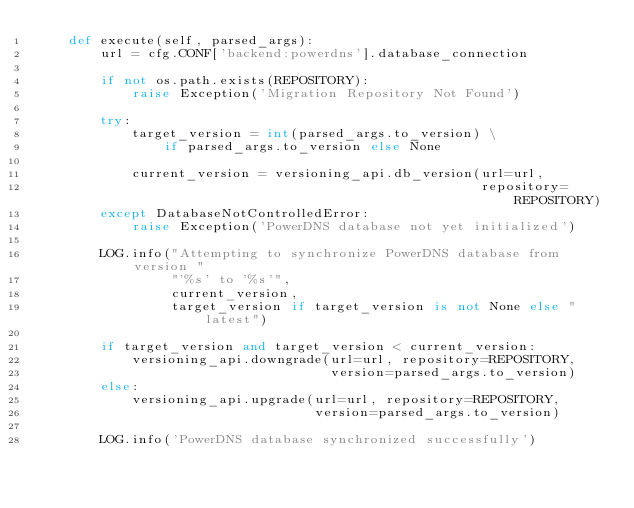Convert code to text. <code><loc_0><loc_0><loc_500><loc_500><_Python_>    def execute(self, parsed_args):
        url = cfg.CONF['backend:powerdns'].database_connection

        if not os.path.exists(REPOSITORY):
            raise Exception('Migration Repository Not Found')

        try:
            target_version = int(parsed_args.to_version) \
                if parsed_args.to_version else None

            current_version = versioning_api.db_version(url=url,
                                                        repository=REPOSITORY)
        except DatabaseNotControlledError:
            raise Exception('PowerDNS database not yet initialized')

        LOG.info("Attempting to synchronize PowerDNS database from version "
                 "'%s' to '%s'",
                 current_version,
                 target_version if target_version is not None else "latest")

        if target_version and target_version < current_version:
            versioning_api.downgrade(url=url, repository=REPOSITORY,
                                     version=parsed_args.to_version)
        else:
            versioning_api.upgrade(url=url, repository=REPOSITORY,
                                   version=parsed_args.to_version)

        LOG.info('PowerDNS database synchronized successfully')
</code> 